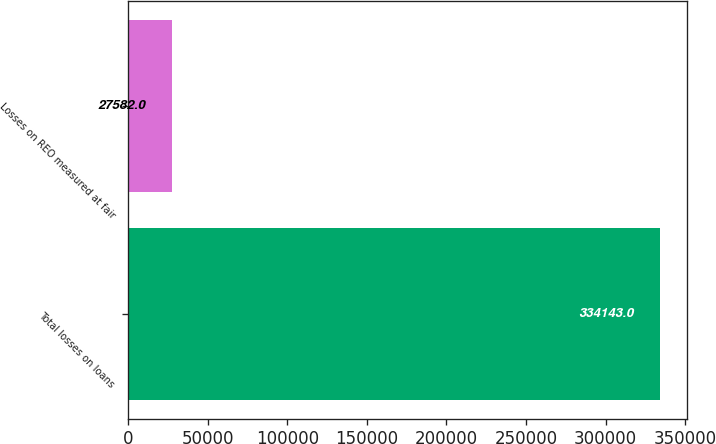Convert chart. <chart><loc_0><loc_0><loc_500><loc_500><bar_chart><fcel>Total losses on loans<fcel>Losses on REO measured at fair<nl><fcel>334143<fcel>27582<nl></chart> 